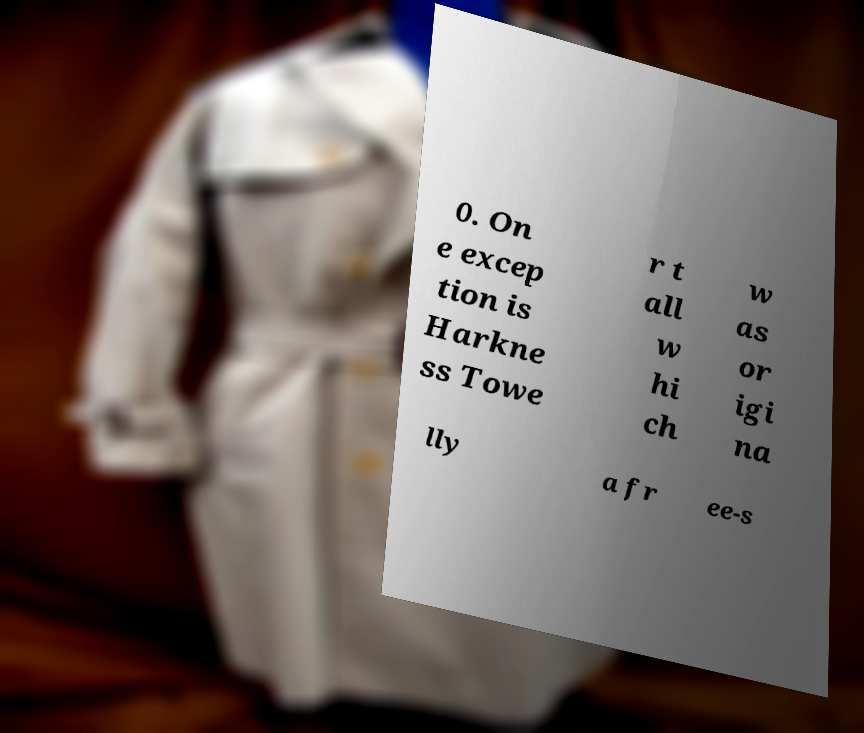Please identify and transcribe the text found in this image. 0. On e excep tion is Harkne ss Towe r t all w hi ch w as or igi na lly a fr ee-s 